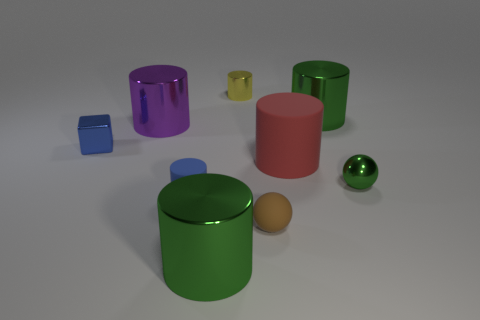Subtract 3 cylinders. How many cylinders are left? 3 Subtract all yellow cylinders. How many cylinders are left? 5 Subtract all small yellow shiny cylinders. How many cylinders are left? 5 Subtract all blue cylinders. Subtract all blue blocks. How many cylinders are left? 5 Subtract all cubes. How many objects are left? 8 Add 9 small green spheres. How many small green spheres exist? 10 Subtract 0 purple balls. How many objects are left? 9 Subtract all big purple matte blocks. Subtract all large purple objects. How many objects are left? 8 Add 4 yellow cylinders. How many yellow cylinders are left? 5 